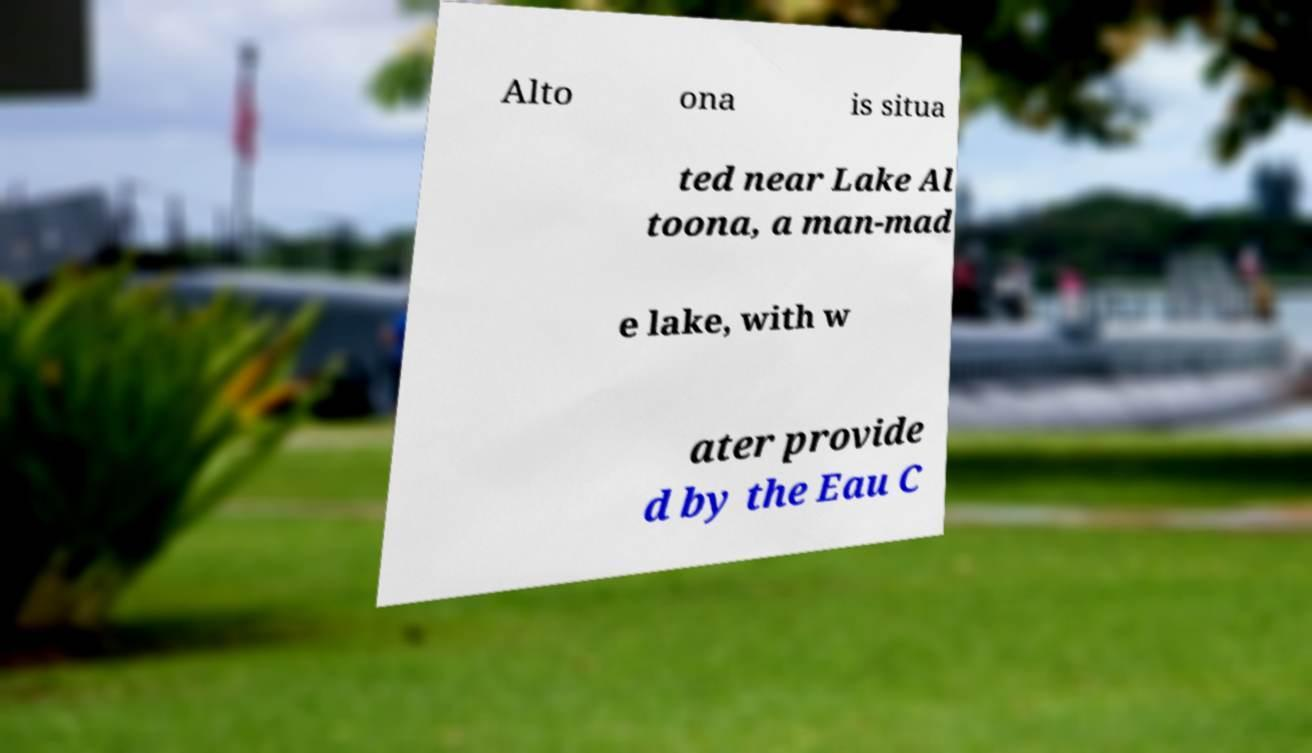Can you read and provide the text displayed in the image?This photo seems to have some interesting text. Can you extract and type it out for me? Alto ona is situa ted near Lake Al toona, a man-mad e lake, with w ater provide d by the Eau C 